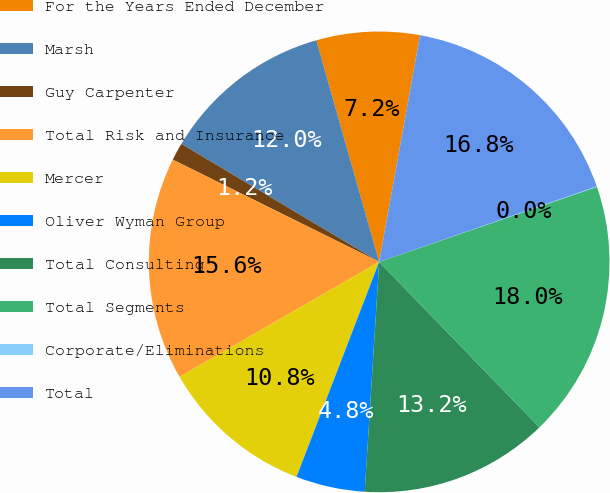Convert chart to OTSL. <chart><loc_0><loc_0><loc_500><loc_500><pie_chart><fcel>For the Years Ended December<fcel>Marsh<fcel>Guy Carpenter<fcel>Total Risk and Insurance<fcel>Mercer<fcel>Oliver Wyman Group<fcel>Total Consulting<fcel>Total Segments<fcel>Corporate/Eliminations<fcel>Total<nl><fcel>7.24%<fcel>12.04%<fcel>1.24%<fcel>15.64%<fcel>10.84%<fcel>4.84%<fcel>13.24%<fcel>18.04%<fcel>0.04%<fcel>16.84%<nl></chart> 